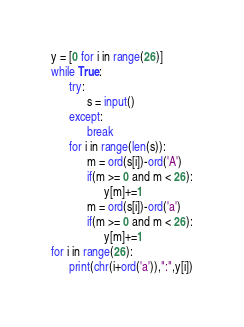Convert code to text. <code><loc_0><loc_0><loc_500><loc_500><_Python_>y = [0 for i in range(26)]
while True:
      try:
            s = input()
      except:
            break
      for i in range(len(s)):
            m = ord(s[i])-ord('A')
            if(m >= 0 and m < 26):
                  y[m]+=1
            m = ord(s[i])-ord('a')
            if(m >= 0 and m < 26):
                  y[m]+=1
for i in range(26):
      print(chr(i+ord('a')),":",y[i])
</code> 